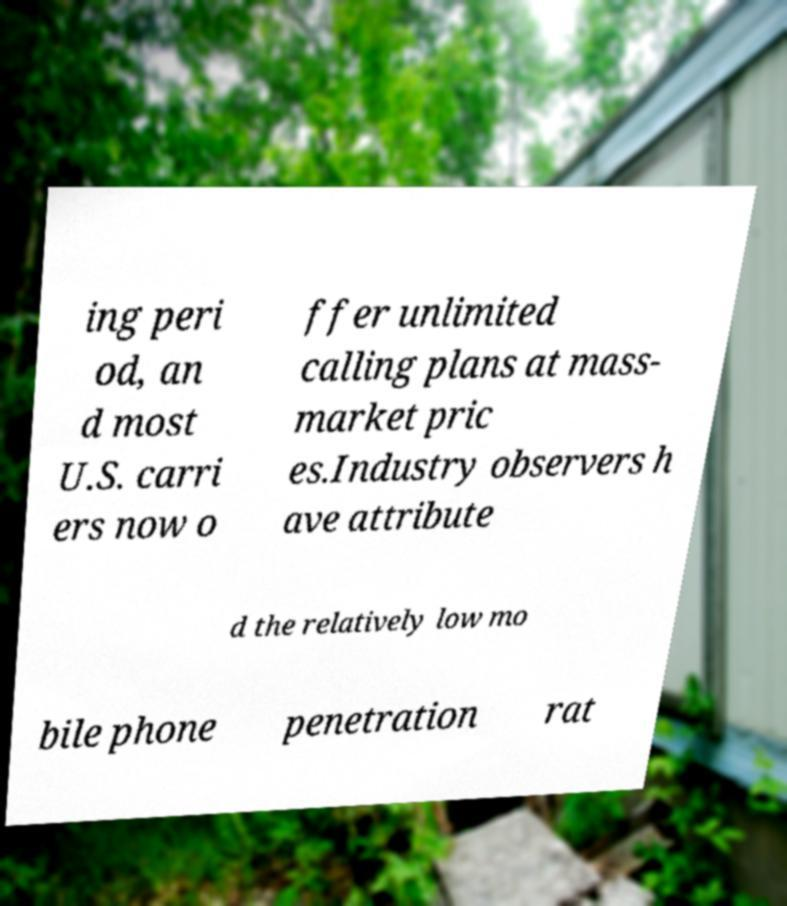What messages or text are displayed in this image? I need them in a readable, typed format. ing peri od, an d most U.S. carri ers now o ffer unlimited calling plans at mass- market pric es.Industry observers h ave attribute d the relatively low mo bile phone penetration rat 